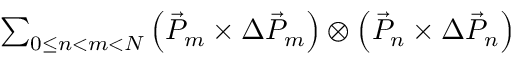<formula> <loc_0><loc_0><loc_500><loc_500>\begin{array} { r } { \sum _ { 0 \leq n < m < N } \left ( \vec { P } _ { m } \times \Delta \vec { P } _ { m } \right ) \otimes \left ( \vec { P } _ { n } \times \Delta \vec { P } _ { n } \right ) } \end{array}</formula> 